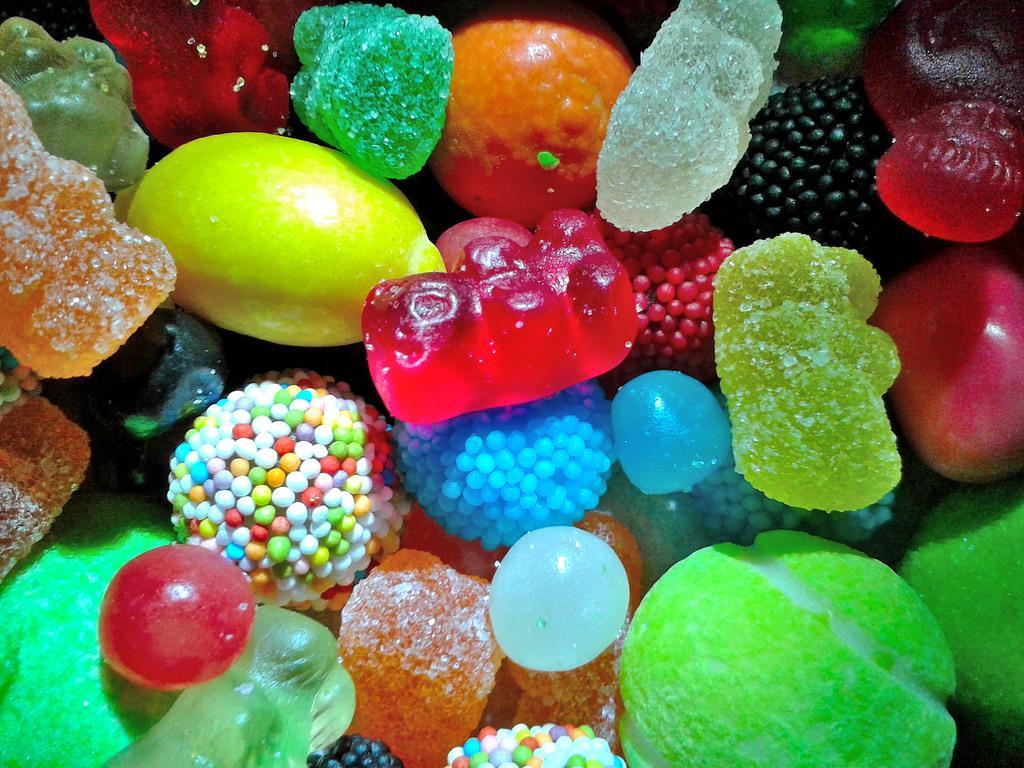Could you give a brief overview of what you see in this image? In this image we can see different types of jellies and candies. 